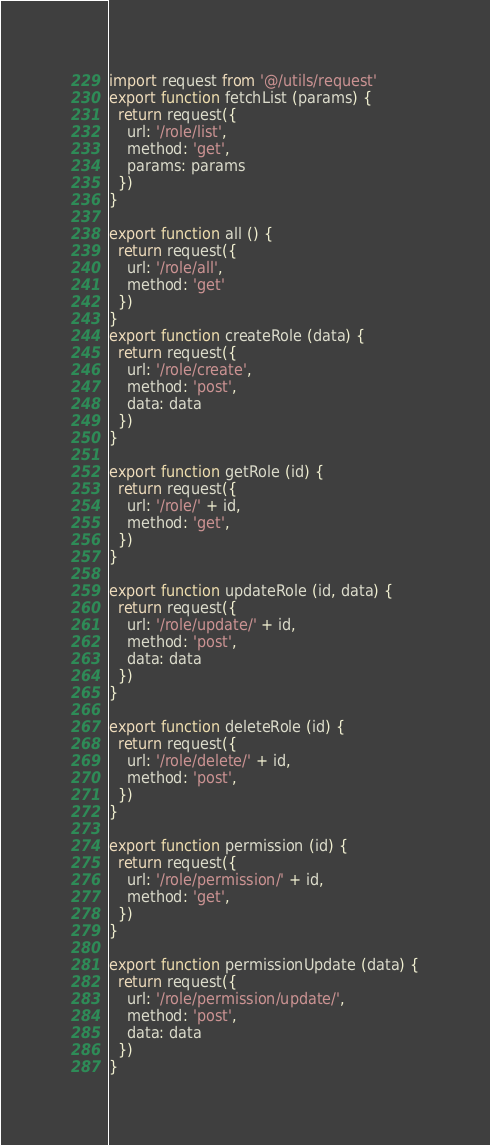<code> <loc_0><loc_0><loc_500><loc_500><_JavaScript_>import request from '@/utils/request'
export function fetchList (params) {
  return request({
    url: '/role/list',
    method: 'get',
    params: params
  })
}

export function all () {
  return request({
    url: '/role/all',
    method: 'get'
  })
}
export function createRole (data) {
  return request({
    url: '/role/create',
    method: 'post',
    data: data
  })
}

export function getRole (id) {
  return request({
    url: '/role/' + id,
    method: 'get',
  })
}

export function updateRole (id, data) {
  return request({
    url: '/role/update/' + id,
    method: 'post',
    data: data
  })
}

export function deleteRole (id) {
  return request({
    url: '/role/delete/' + id,
    method: 'post',
  })
}

export function permission (id) {
  return request({
    url: '/role/permission/' + id,
    method: 'get',
  })
}

export function permissionUpdate (data) {
  return request({
    url: '/role/permission/update/',
    method: 'post',
    data: data
  })
}</code> 